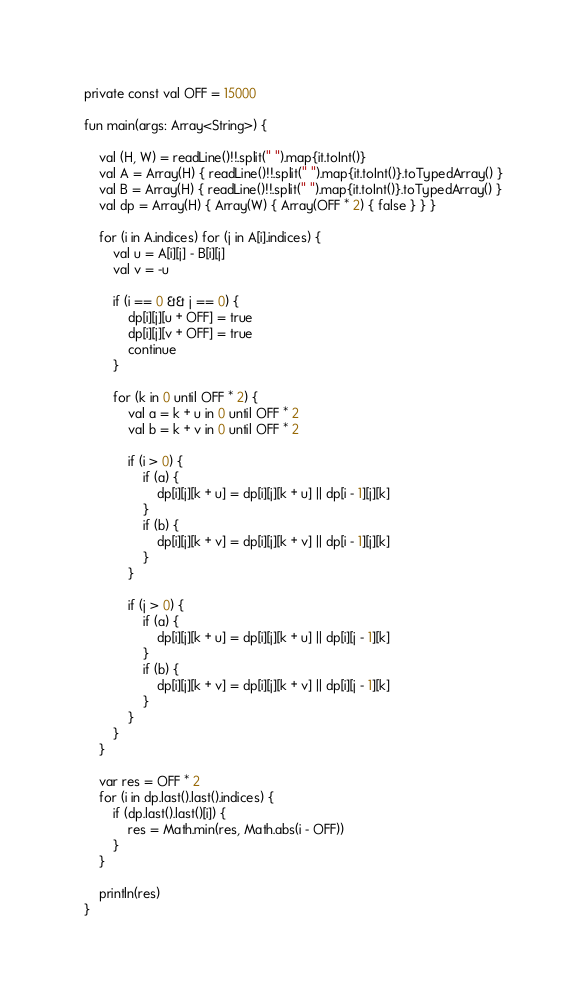<code> <loc_0><loc_0><loc_500><loc_500><_Kotlin_>private const val OFF = 15000

fun main(args: Array<String>) {

    val (H, W) = readLine()!!.split(" ").map{it.toInt()}
    val A = Array(H) { readLine()!!.split(" ").map{it.toInt()}.toTypedArray() }
    val B = Array(H) { readLine()!!.split(" ").map{it.toInt()}.toTypedArray() }
    val dp = Array(H) { Array(W) { Array(OFF * 2) { false } } }

    for (i in A.indices) for (j in A[i].indices) {
        val u = A[i][j] - B[i][j]
        val v = -u

        if (i == 0 && j == 0) {
            dp[i][j][u + OFF] = true
            dp[i][j][v + OFF] = true
            continue
        }

        for (k in 0 until OFF * 2) {
            val a = k + u in 0 until OFF * 2
            val b = k + v in 0 until OFF * 2

            if (i > 0) {
                if (a) {
                    dp[i][j][k + u] = dp[i][j][k + u] || dp[i - 1][j][k]
                }
                if (b) {
                    dp[i][j][k + v] = dp[i][j][k + v] || dp[i - 1][j][k]
                }
            }

            if (j > 0) {
                if (a) {
                    dp[i][j][k + u] = dp[i][j][k + u] || dp[i][j - 1][k]
                }
                if (b) {
                    dp[i][j][k + v] = dp[i][j][k + v] || dp[i][j - 1][k]
                }
            }
        }
    }

    var res = OFF * 2
    for (i in dp.last().last().indices) {
        if (dp.last().last()[i]) {
            res = Math.min(res, Math.abs(i - OFF))
        }
    }

    println(res)
}
</code> 